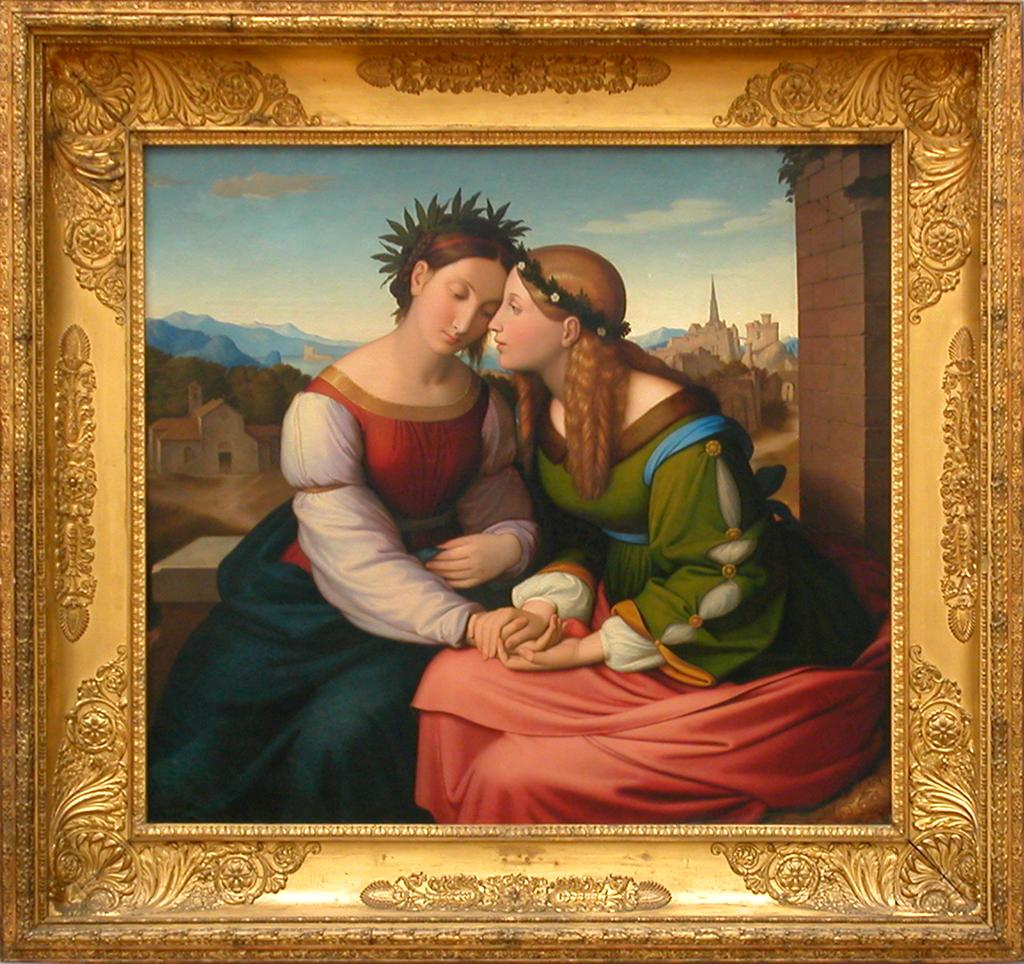What object is present in the image that typically holds a picture? There is a photo frame in the image. What can be seen inside the photo frame? The photo frame contains a picture of two persons. What type of rabbit can be seen hopping near the photo frame in the image? There is no rabbit present in the image; it only features a photo frame with a picture of two persons. 